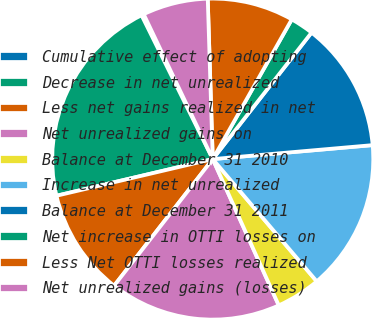Convert chart to OTSL. <chart><loc_0><loc_0><loc_500><loc_500><pie_chart><fcel>Cumulative effect of adopting<fcel>Decrease in net unrealized<fcel>Less net gains realized in net<fcel>Net unrealized gains on<fcel>Balance at December 31 2010<fcel>Increase in net unrealized<fcel>Balance at December 31 2011<fcel>Net increase in OTTI losses on<fcel>Less Net OTTI losses realized<fcel>Net unrealized gains (losses)<nl><fcel>0.24%<fcel>21.35%<fcel>10.8%<fcel>17.28%<fcel>4.47%<fcel>15.17%<fcel>13.06%<fcel>2.36%<fcel>8.69%<fcel>6.58%<nl></chart> 